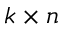Convert formula to latex. <formula><loc_0><loc_0><loc_500><loc_500>k \times n</formula> 